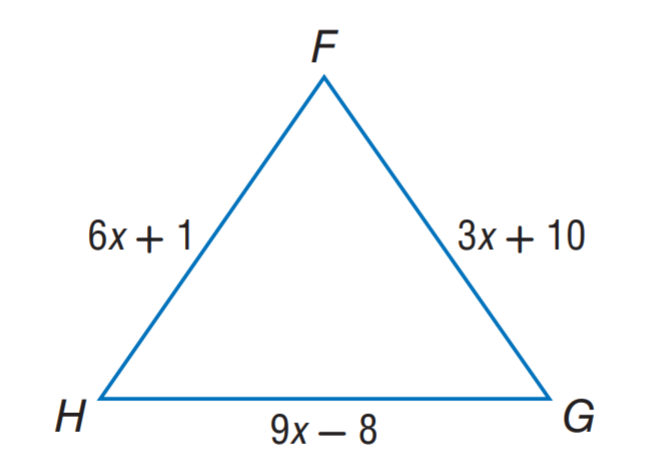Answer the mathemtical geometry problem and directly provide the correct option letter.
Question: \triangle F G H is an equilateral triangle. Find H G.
Choices: A: 3 B: 16 C: 19 D: 22 C 